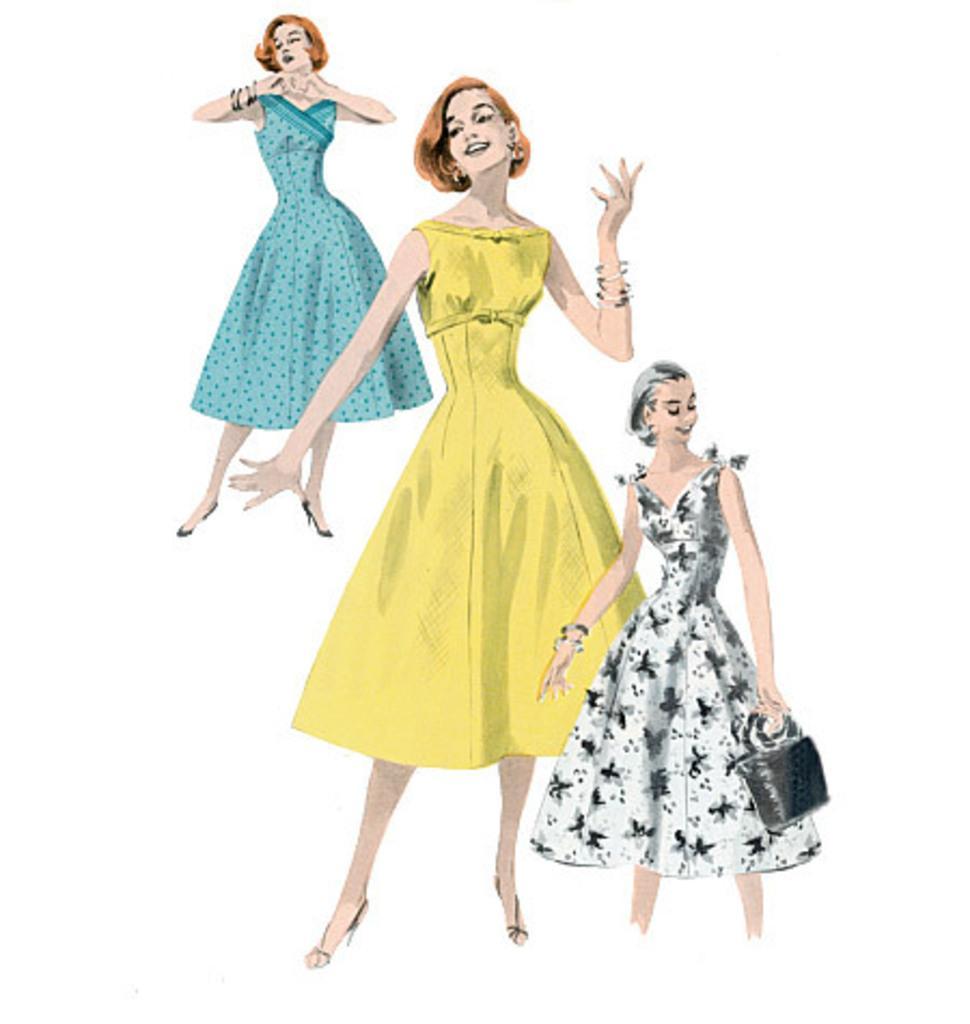Please provide a concise description of this image. There are paintings of three women who are standing and smiling on a white color surface. And the background is white in color. 